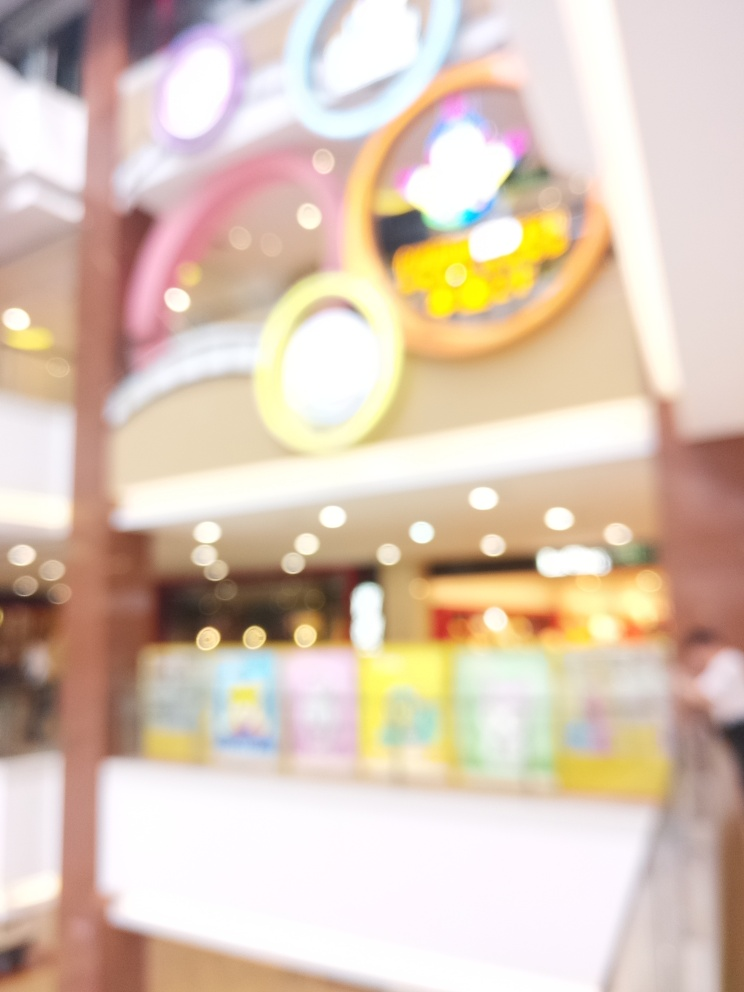Can you describe the elements that are still recognizable despite the blurriness? Despite the overall blurriness, the bright colors and circular shapes are somewhat recognizable. These elements suggest the presence of vibrant signs, possibly part of a shop or advertisement display in a commercial setting. 